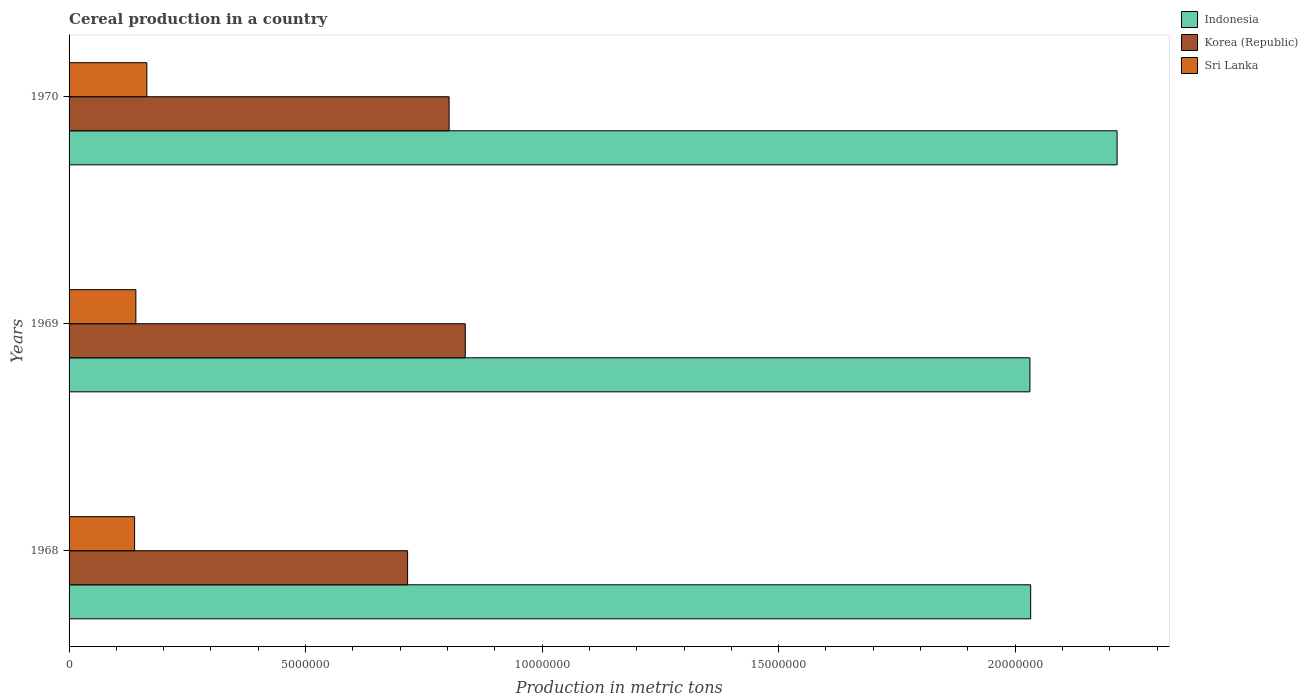How many groups of bars are there?
Keep it short and to the point. 3. How many bars are there on the 3rd tick from the bottom?
Ensure brevity in your answer.  3. What is the label of the 1st group of bars from the top?
Your response must be concise. 1970. What is the total cereal production in Sri Lanka in 1968?
Make the answer very short. 1.39e+06. Across all years, what is the maximum total cereal production in Sri Lanka?
Make the answer very short. 1.64e+06. Across all years, what is the minimum total cereal production in Sri Lanka?
Give a very brief answer. 1.39e+06. In which year was the total cereal production in Korea (Republic) maximum?
Ensure brevity in your answer.  1969. In which year was the total cereal production in Indonesia minimum?
Keep it short and to the point. 1969. What is the total total cereal production in Korea (Republic) in the graph?
Offer a very short reply. 2.36e+07. What is the difference between the total cereal production in Indonesia in 1968 and that in 1969?
Offer a terse response. 1.58e+04. What is the difference between the total cereal production in Indonesia in 1969 and the total cereal production in Sri Lanka in 1968?
Keep it short and to the point. 1.89e+07. What is the average total cereal production in Korea (Republic) per year?
Your answer should be very brief. 7.86e+06. In the year 1970, what is the difference between the total cereal production in Korea (Republic) and total cereal production in Sri Lanka?
Your answer should be compact. 6.39e+06. In how many years, is the total cereal production in Sri Lanka greater than 3000000 metric tons?
Ensure brevity in your answer.  0. What is the ratio of the total cereal production in Indonesia in 1969 to that in 1970?
Give a very brief answer. 0.92. Is the total cereal production in Indonesia in 1968 less than that in 1969?
Provide a succinct answer. No. Is the difference between the total cereal production in Korea (Republic) in 1969 and 1970 greater than the difference between the total cereal production in Sri Lanka in 1969 and 1970?
Ensure brevity in your answer.  Yes. What is the difference between the highest and the second highest total cereal production in Sri Lanka?
Give a very brief answer. 2.32e+05. What is the difference between the highest and the lowest total cereal production in Indonesia?
Your response must be concise. 1.84e+06. In how many years, is the total cereal production in Korea (Republic) greater than the average total cereal production in Korea (Republic) taken over all years?
Offer a very short reply. 2. Is the sum of the total cereal production in Korea (Republic) in 1968 and 1969 greater than the maximum total cereal production in Sri Lanka across all years?
Make the answer very short. Yes. What does the 2nd bar from the top in 1968 represents?
Make the answer very short. Korea (Republic). What does the 3rd bar from the bottom in 1969 represents?
Offer a terse response. Sri Lanka. How many bars are there?
Make the answer very short. 9. Are all the bars in the graph horizontal?
Provide a succinct answer. Yes. How many years are there in the graph?
Keep it short and to the point. 3. Are the values on the major ticks of X-axis written in scientific E-notation?
Ensure brevity in your answer.  No. Does the graph contain grids?
Your answer should be very brief. No. Where does the legend appear in the graph?
Provide a succinct answer. Top right. How many legend labels are there?
Your answer should be compact. 3. What is the title of the graph?
Ensure brevity in your answer.  Cereal production in a country. What is the label or title of the X-axis?
Ensure brevity in your answer.  Production in metric tons. What is the Production in metric tons in Indonesia in 1968?
Your response must be concise. 2.03e+07. What is the Production in metric tons in Korea (Republic) in 1968?
Provide a short and direct response. 7.16e+06. What is the Production in metric tons of Sri Lanka in 1968?
Give a very brief answer. 1.39e+06. What is the Production in metric tons of Indonesia in 1969?
Ensure brevity in your answer.  2.03e+07. What is the Production in metric tons of Korea (Republic) in 1969?
Provide a short and direct response. 8.38e+06. What is the Production in metric tons in Sri Lanka in 1969?
Your answer should be very brief. 1.41e+06. What is the Production in metric tons in Indonesia in 1970?
Your response must be concise. 2.22e+07. What is the Production in metric tons of Korea (Republic) in 1970?
Offer a very short reply. 8.03e+06. What is the Production in metric tons in Sri Lanka in 1970?
Your response must be concise. 1.64e+06. Across all years, what is the maximum Production in metric tons of Indonesia?
Ensure brevity in your answer.  2.22e+07. Across all years, what is the maximum Production in metric tons of Korea (Republic)?
Offer a very short reply. 8.38e+06. Across all years, what is the maximum Production in metric tons in Sri Lanka?
Provide a succinct answer. 1.64e+06. Across all years, what is the minimum Production in metric tons of Indonesia?
Provide a short and direct response. 2.03e+07. Across all years, what is the minimum Production in metric tons in Korea (Republic)?
Give a very brief answer. 7.16e+06. Across all years, what is the minimum Production in metric tons in Sri Lanka?
Provide a short and direct response. 1.39e+06. What is the total Production in metric tons in Indonesia in the graph?
Your answer should be compact. 6.28e+07. What is the total Production in metric tons of Korea (Republic) in the graph?
Your answer should be very brief. 2.36e+07. What is the total Production in metric tons in Sri Lanka in the graph?
Offer a very short reply. 4.44e+06. What is the difference between the Production in metric tons of Indonesia in 1968 and that in 1969?
Make the answer very short. 1.58e+04. What is the difference between the Production in metric tons of Korea (Republic) in 1968 and that in 1969?
Provide a short and direct response. -1.22e+06. What is the difference between the Production in metric tons in Sri Lanka in 1968 and that in 1969?
Give a very brief answer. -2.67e+04. What is the difference between the Production in metric tons of Indonesia in 1968 and that in 1970?
Make the answer very short. -1.83e+06. What is the difference between the Production in metric tons in Korea (Republic) in 1968 and that in 1970?
Offer a terse response. -8.77e+05. What is the difference between the Production in metric tons in Sri Lanka in 1968 and that in 1970?
Your answer should be compact. -2.59e+05. What is the difference between the Production in metric tons in Indonesia in 1969 and that in 1970?
Offer a terse response. -1.84e+06. What is the difference between the Production in metric tons of Korea (Republic) in 1969 and that in 1970?
Your answer should be compact. 3.42e+05. What is the difference between the Production in metric tons of Sri Lanka in 1969 and that in 1970?
Make the answer very short. -2.32e+05. What is the difference between the Production in metric tons of Indonesia in 1968 and the Production in metric tons of Korea (Republic) in 1969?
Ensure brevity in your answer.  1.20e+07. What is the difference between the Production in metric tons of Indonesia in 1968 and the Production in metric tons of Sri Lanka in 1969?
Ensure brevity in your answer.  1.89e+07. What is the difference between the Production in metric tons of Korea (Republic) in 1968 and the Production in metric tons of Sri Lanka in 1969?
Provide a succinct answer. 5.74e+06. What is the difference between the Production in metric tons of Indonesia in 1968 and the Production in metric tons of Korea (Republic) in 1970?
Your answer should be very brief. 1.23e+07. What is the difference between the Production in metric tons in Indonesia in 1968 and the Production in metric tons in Sri Lanka in 1970?
Offer a terse response. 1.87e+07. What is the difference between the Production in metric tons in Korea (Republic) in 1968 and the Production in metric tons in Sri Lanka in 1970?
Give a very brief answer. 5.51e+06. What is the difference between the Production in metric tons of Indonesia in 1969 and the Production in metric tons of Korea (Republic) in 1970?
Give a very brief answer. 1.23e+07. What is the difference between the Production in metric tons in Indonesia in 1969 and the Production in metric tons in Sri Lanka in 1970?
Your response must be concise. 1.87e+07. What is the difference between the Production in metric tons of Korea (Republic) in 1969 and the Production in metric tons of Sri Lanka in 1970?
Keep it short and to the point. 6.73e+06. What is the average Production in metric tons of Indonesia per year?
Provide a succinct answer. 2.09e+07. What is the average Production in metric tons of Korea (Republic) per year?
Ensure brevity in your answer.  7.86e+06. What is the average Production in metric tons in Sri Lanka per year?
Offer a terse response. 1.48e+06. In the year 1968, what is the difference between the Production in metric tons in Indonesia and Production in metric tons in Korea (Republic)?
Your answer should be very brief. 1.32e+07. In the year 1968, what is the difference between the Production in metric tons of Indonesia and Production in metric tons of Sri Lanka?
Provide a succinct answer. 1.89e+07. In the year 1968, what is the difference between the Production in metric tons in Korea (Republic) and Production in metric tons in Sri Lanka?
Provide a succinct answer. 5.77e+06. In the year 1969, what is the difference between the Production in metric tons of Indonesia and Production in metric tons of Korea (Republic)?
Your response must be concise. 1.19e+07. In the year 1969, what is the difference between the Production in metric tons in Indonesia and Production in metric tons in Sri Lanka?
Provide a short and direct response. 1.89e+07. In the year 1969, what is the difference between the Production in metric tons of Korea (Republic) and Production in metric tons of Sri Lanka?
Provide a succinct answer. 6.96e+06. In the year 1970, what is the difference between the Production in metric tons in Indonesia and Production in metric tons in Korea (Republic)?
Offer a very short reply. 1.41e+07. In the year 1970, what is the difference between the Production in metric tons of Indonesia and Production in metric tons of Sri Lanka?
Keep it short and to the point. 2.05e+07. In the year 1970, what is the difference between the Production in metric tons of Korea (Republic) and Production in metric tons of Sri Lanka?
Your answer should be very brief. 6.39e+06. What is the ratio of the Production in metric tons in Indonesia in 1968 to that in 1969?
Offer a terse response. 1. What is the ratio of the Production in metric tons in Korea (Republic) in 1968 to that in 1969?
Offer a very short reply. 0.85. What is the ratio of the Production in metric tons of Sri Lanka in 1968 to that in 1969?
Provide a succinct answer. 0.98. What is the ratio of the Production in metric tons in Indonesia in 1968 to that in 1970?
Your response must be concise. 0.92. What is the ratio of the Production in metric tons of Korea (Republic) in 1968 to that in 1970?
Make the answer very short. 0.89. What is the ratio of the Production in metric tons in Sri Lanka in 1968 to that in 1970?
Provide a succinct answer. 0.84. What is the ratio of the Production in metric tons of Indonesia in 1969 to that in 1970?
Your answer should be compact. 0.92. What is the ratio of the Production in metric tons in Korea (Republic) in 1969 to that in 1970?
Provide a succinct answer. 1.04. What is the ratio of the Production in metric tons of Sri Lanka in 1969 to that in 1970?
Make the answer very short. 0.86. What is the difference between the highest and the second highest Production in metric tons in Indonesia?
Provide a short and direct response. 1.83e+06. What is the difference between the highest and the second highest Production in metric tons of Korea (Republic)?
Offer a very short reply. 3.42e+05. What is the difference between the highest and the second highest Production in metric tons in Sri Lanka?
Offer a very short reply. 2.32e+05. What is the difference between the highest and the lowest Production in metric tons in Indonesia?
Provide a short and direct response. 1.84e+06. What is the difference between the highest and the lowest Production in metric tons in Korea (Republic)?
Provide a short and direct response. 1.22e+06. What is the difference between the highest and the lowest Production in metric tons in Sri Lanka?
Keep it short and to the point. 2.59e+05. 